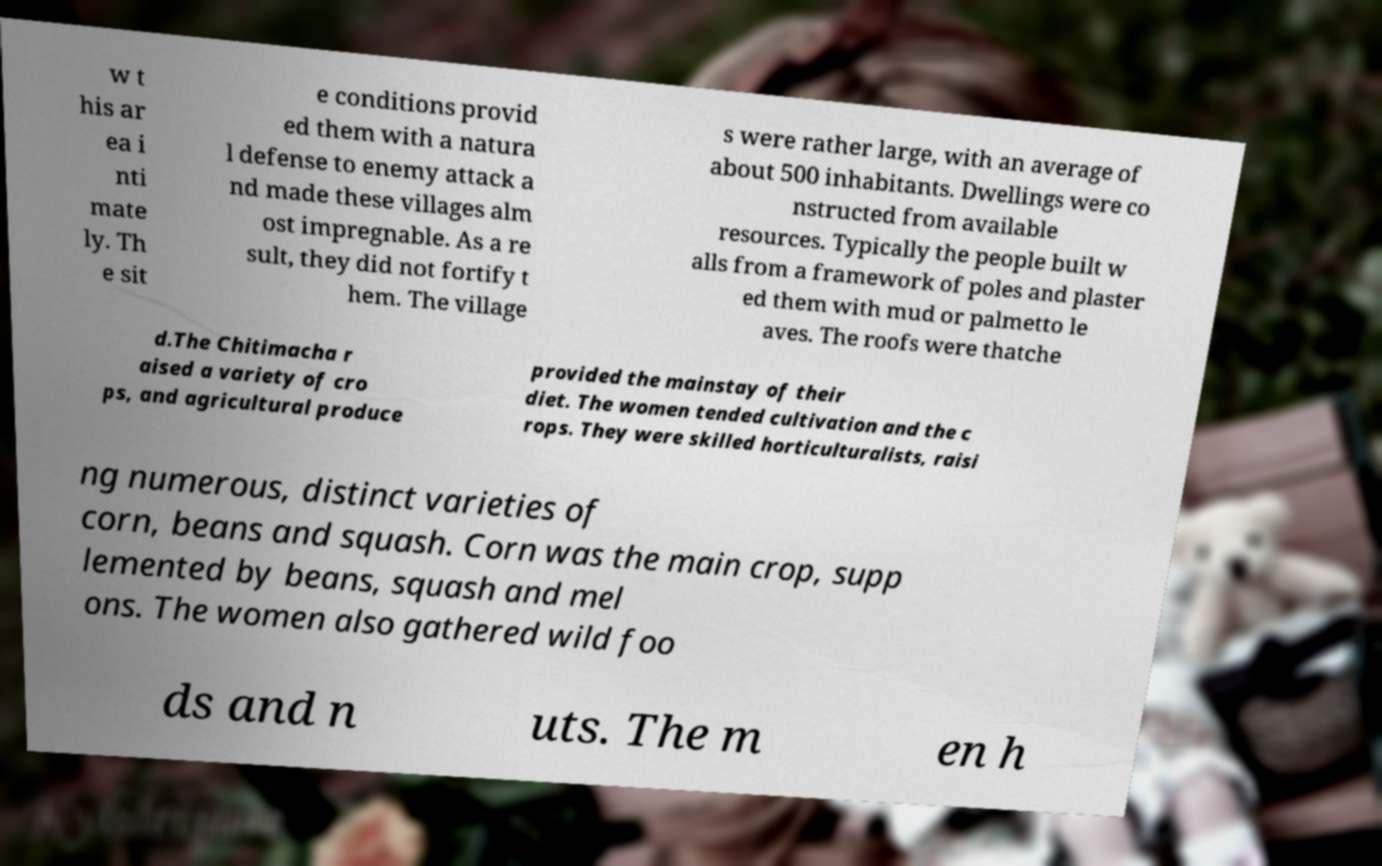Please identify and transcribe the text found in this image. w t his ar ea i nti mate ly. Th e sit e conditions provid ed them with a natura l defense to enemy attack a nd made these villages alm ost impregnable. As a re sult, they did not fortify t hem. The village s were rather large, with an average of about 500 inhabitants. Dwellings were co nstructed from available resources. Typically the people built w alls from a framework of poles and plaster ed them with mud or palmetto le aves. The roofs were thatche d.The Chitimacha r aised a variety of cro ps, and agricultural produce provided the mainstay of their diet. The women tended cultivation and the c rops. They were skilled horticulturalists, raisi ng numerous, distinct varieties of corn, beans and squash. Corn was the main crop, supp lemented by beans, squash and mel ons. The women also gathered wild foo ds and n uts. The m en h 